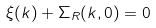<formula> <loc_0><loc_0><loc_500><loc_500>\xi ( k ) + \Sigma _ { R } ( k , 0 ) = 0</formula> 